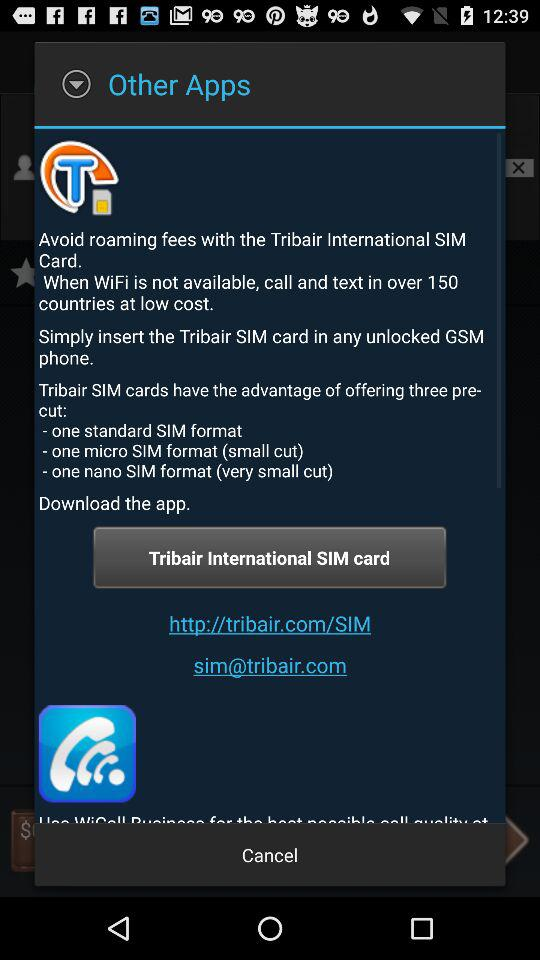How many countries are mentioned in the description?
Answer the question using a single word or phrase. 150 